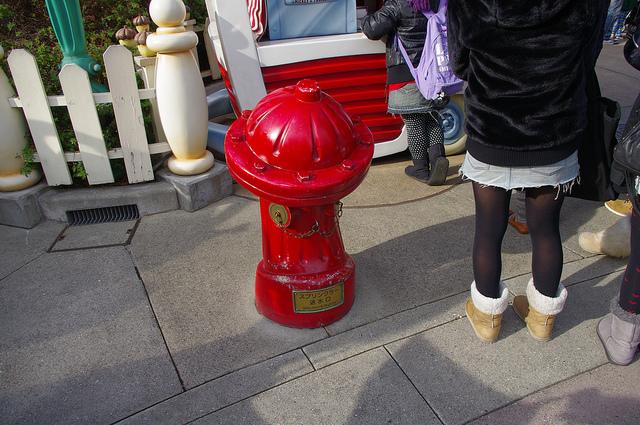Does this appear to be a cold day?
Give a very brief answer. Yes. How many slats are in the fence?
Be succinct. 3. Is the fire hydrant cartoonish?
Short answer required. Yes. 